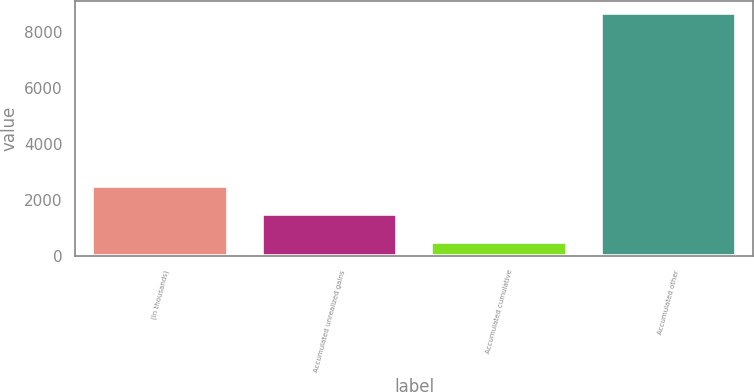Convert chart. <chart><loc_0><loc_0><loc_500><loc_500><bar_chart><fcel>(In thousands)<fcel>Accumulated unrealized gains<fcel>Accumulated cumulative<fcel>Accumulated other<nl><fcel>2496.6<fcel>1493.8<fcel>491<fcel>8660<nl></chart> 